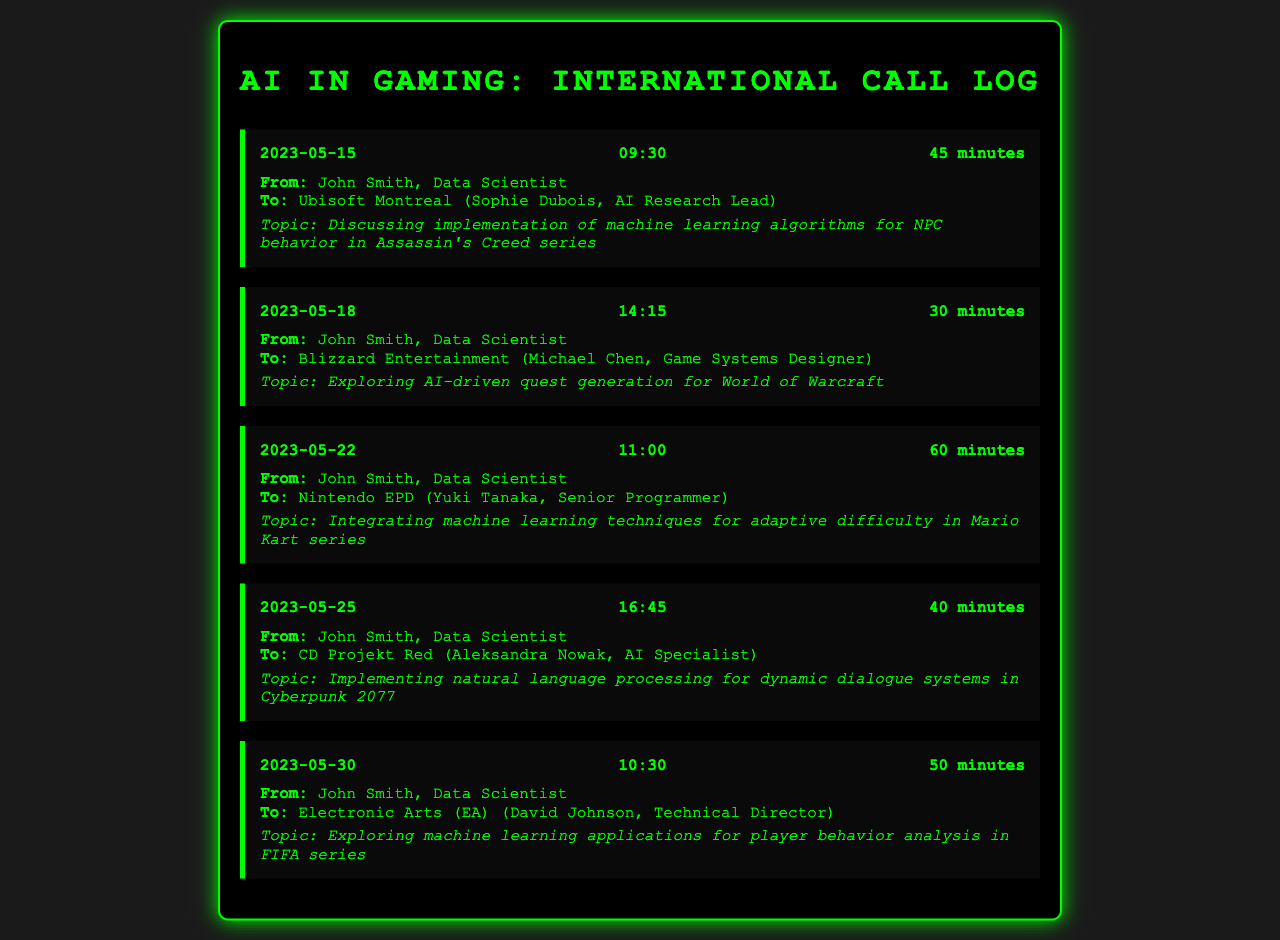What is the date of the call with Ubisoft Montreal? The date of the call with Ubisoft Montreal is specified in the log as 2023-05-15.
Answer: 2023-05-15 Who did John Smith speak to at Blizzard Entertainment? The document specifies that John Smith spoke to Michael Chen, the Game Systems Designer at Blizzard Entertainment.
Answer: Michael Chen What was the duration of the call with Nintendo EPD? The call with Nintendo EPD lasted for 60 minutes, as indicated in the call log.
Answer: 60 minutes What topic was discussed during the call with CD Projekt Red? The topic discussed during the call with CD Projekt Red was the implementation of natural language processing for dynamic dialogue systems in Cyberpunk 2077.
Answer: Implementing natural language processing for dynamic dialogue systems in Cyberpunk 2077 How many calls were made in total? The document lists a total of five calls that were made, as seen in the call entries.
Answer: Five What can be inferred about the focus of the calls? The focus of the calls seems to be on implementing AI and machine learning techniques in various video games, suggesting a collective interest in advancing interactive media.
Answer: AI and machine learning techniques Who is the Technical Director that John Smith spoke to at Electronic Arts? The Technical Director that John Smith spoke to at Electronic Arts is David Johnson, according to the information in the log.
Answer: David Johnson What call topic involved adaptive difficulty? The call topic involving adaptive difficulty pertains to integrating machine learning techniques in the Mario Kart series.
Answer: Integrating machine learning techniques for adaptive difficulty in Mario Kart series 